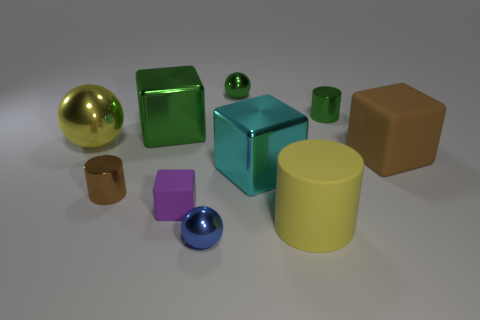Subtract all blocks. How many objects are left? 6 Add 8 large yellow matte cylinders. How many large yellow matte cylinders are left? 9 Add 5 large matte cylinders. How many large matte cylinders exist? 6 Subtract 1 brown cylinders. How many objects are left? 9 Subtract all large matte cubes. Subtract all tiny cyan metal cylinders. How many objects are left? 9 